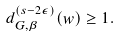<formula> <loc_0><loc_0><loc_500><loc_500>d _ { G , \beta } ^ { ( s - 2 \epsilon ) } ( w ) \geq 1 .</formula> 